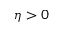<formula> <loc_0><loc_0><loc_500><loc_500>\eta > 0</formula> 